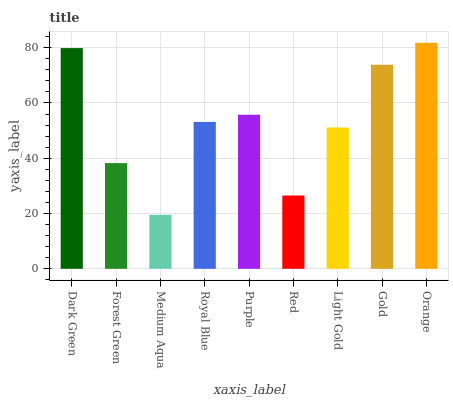Is Medium Aqua the minimum?
Answer yes or no. Yes. Is Orange the maximum?
Answer yes or no. Yes. Is Forest Green the minimum?
Answer yes or no. No. Is Forest Green the maximum?
Answer yes or no. No. Is Dark Green greater than Forest Green?
Answer yes or no. Yes. Is Forest Green less than Dark Green?
Answer yes or no. Yes. Is Forest Green greater than Dark Green?
Answer yes or no. No. Is Dark Green less than Forest Green?
Answer yes or no. No. Is Royal Blue the high median?
Answer yes or no. Yes. Is Royal Blue the low median?
Answer yes or no. Yes. Is Red the high median?
Answer yes or no. No. Is Dark Green the low median?
Answer yes or no. No. 